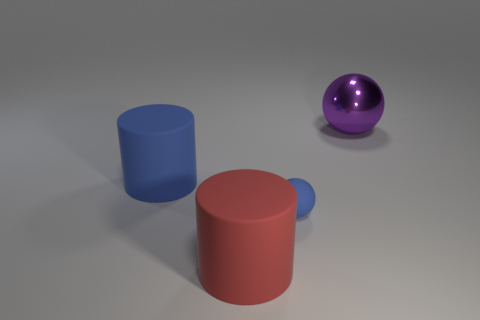Add 1 small purple spheres. How many objects exist? 5 Add 4 cyan matte things. How many cyan matte things exist? 4 Subtract 0 yellow cylinders. How many objects are left? 4 Subtract all large red cylinders. Subtract all big metal things. How many objects are left? 2 Add 3 small rubber spheres. How many small rubber spheres are left? 4 